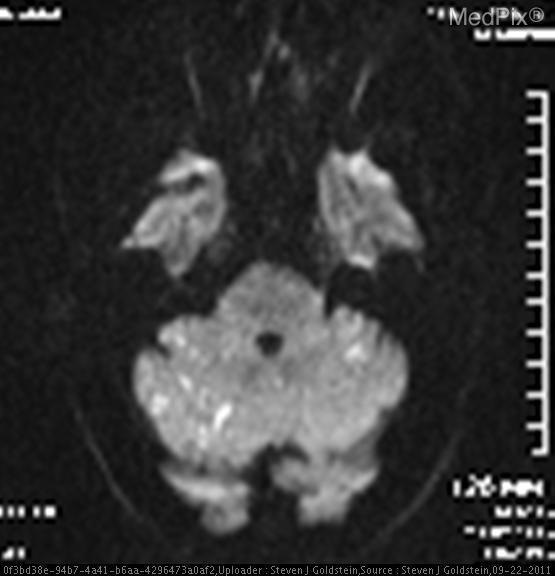What type of thrombosis is shown?
Write a very short answer. Basilar artery thrombosis. Where do we see multiple infarcts in the above image?
Give a very brief answer. Cerebellum. Location of the multiple infarcts?
Be succinct. Cerebellum. What organ system is shown in the above image?
Quick response, please. Brain. Which organ system is shown in the image?
Give a very brief answer. Brain. How was this mri taken?
Short answer required. Dwi. What type of mri is this?
Concise answer only. Dwi. 